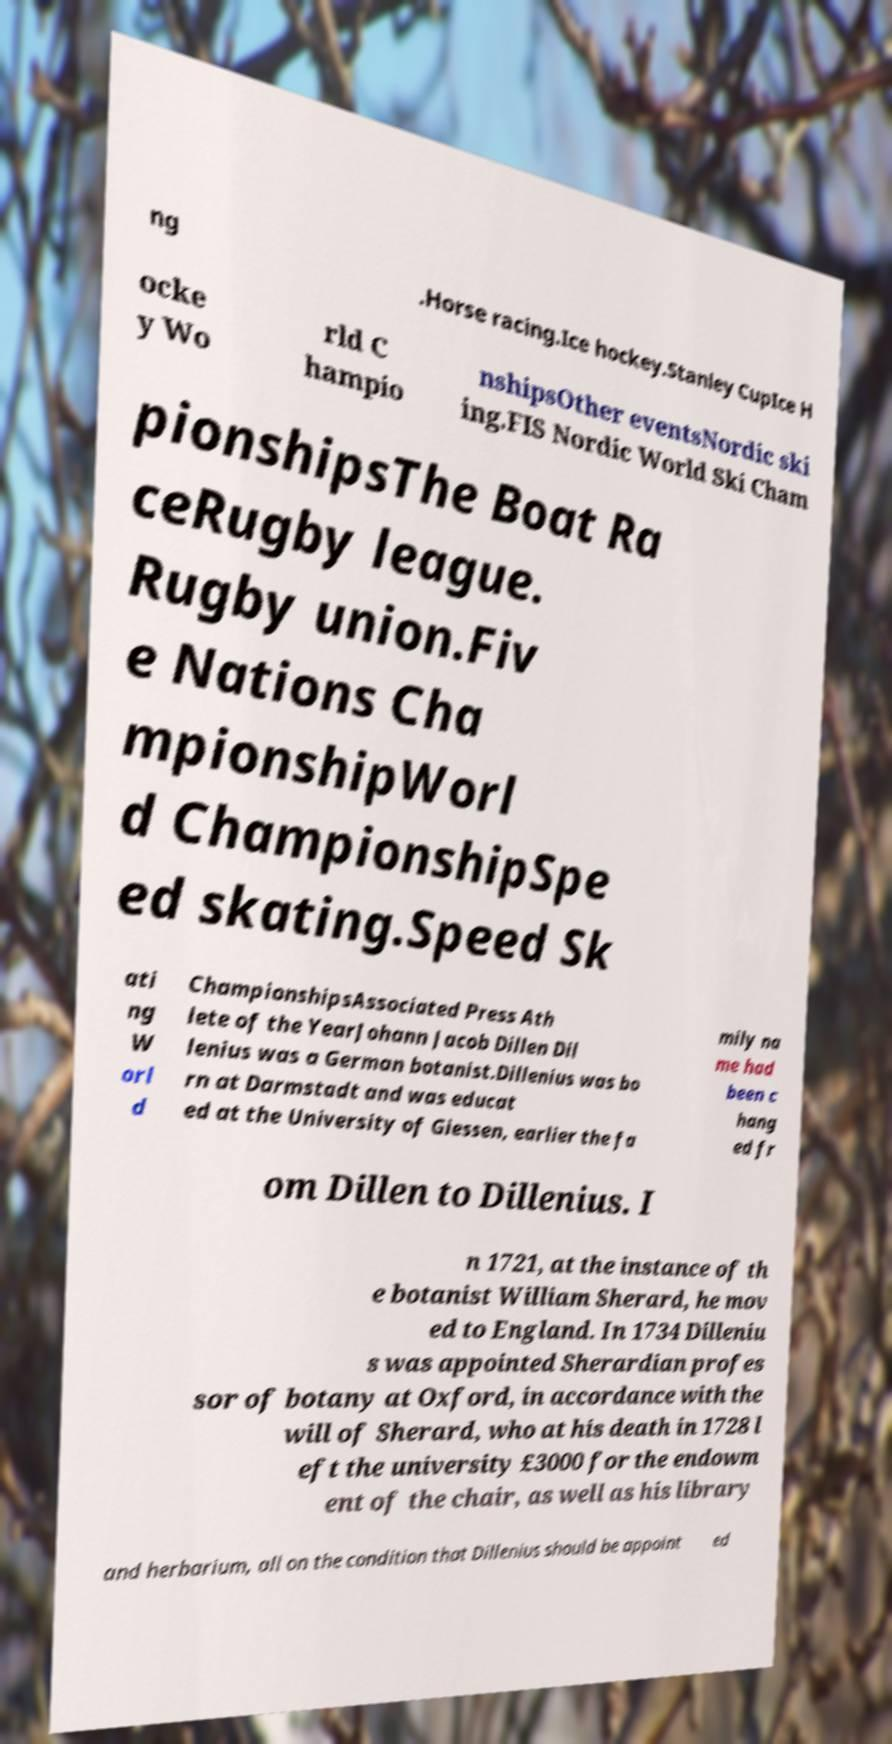Could you assist in decoding the text presented in this image and type it out clearly? ng .Horse racing.Ice hockey.Stanley CupIce H ocke y Wo rld C hampio nshipsOther eventsNordic ski ing.FIS Nordic World Ski Cham pionshipsThe Boat Ra ceRugby league. Rugby union.Fiv e Nations Cha mpionshipWorl d ChampionshipSpe ed skating.Speed Sk ati ng W orl d ChampionshipsAssociated Press Ath lete of the YearJohann Jacob Dillen Dil lenius was a German botanist.Dillenius was bo rn at Darmstadt and was educat ed at the University of Giessen, earlier the fa mily na me had been c hang ed fr om Dillen to Dillenius. I n 1721, at the instance of th e botanist William Sherard, he mov ed to England. In 1734 Dilleniu s was appointed Sherardian profes sor of botany at Oxford, in accordance with the will of Sherard, who at his death in 1728 l eft the university £3000 for the endowm ent of the chair, as well as his library and herbarium, all on the condition that Dillenius should be appoint ed 